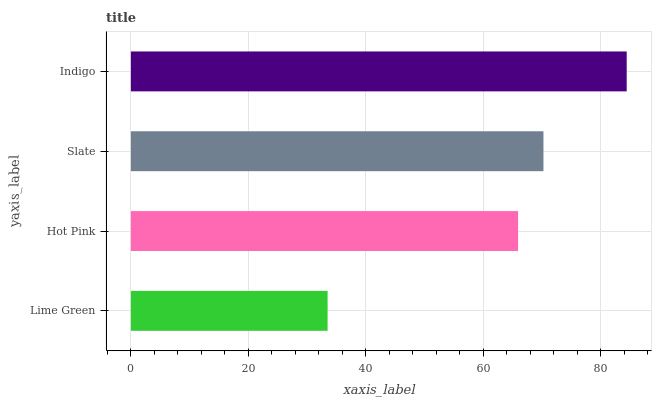Is Lime Green the minimum?
Answer yes or no. Yes. Is Indigo the maximum?
Answer yes or no. Yes. Is Hot Pink the minimum?
Answer yes or no. No. Is Hot Pink the maximum?
Answer yes or no. No. Is Hot Pink greater than Lime Green?
Answer yes or no. Yes. Is Lime Green less than Hot Pink?
Answer yes or no. Yes. Is Lime Green greater than Hot Pink?
Answer yes or no. No. Is Hot Pink less than Lime Green?
Answer yes or no. No. Is Slate the high median?
Answer yes or no. Yes. Is Hot Pink the low median?
Answer yes or no. Yes. Is Indigo the high median?
Answer yes or no. No. Is Lime Green the low median?
Answer yes or no. No. 